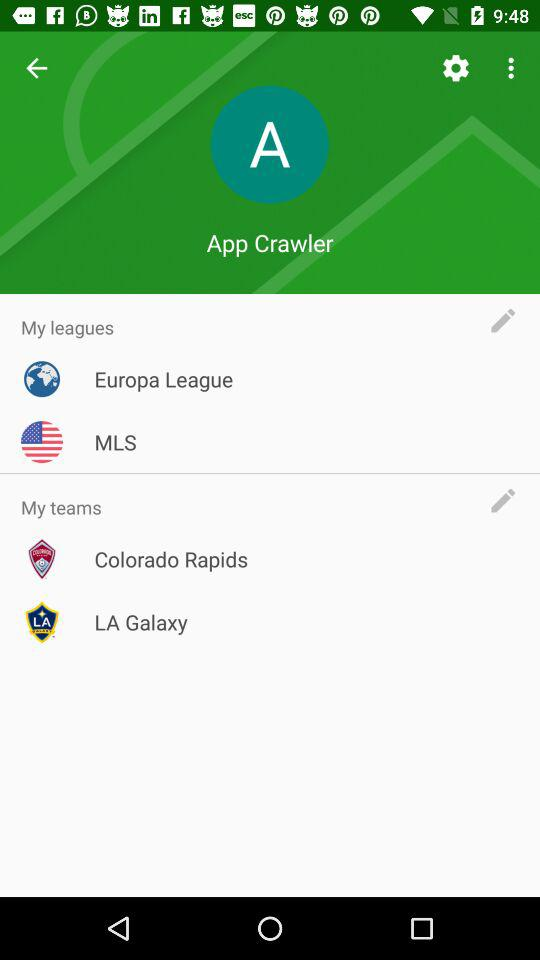What is the given profile name? The given profile name is App Crawler. 